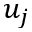Convert formula to latex. <formula><loc_0><loc_0><loc_500><loc_500>u _ { j }</formula> 